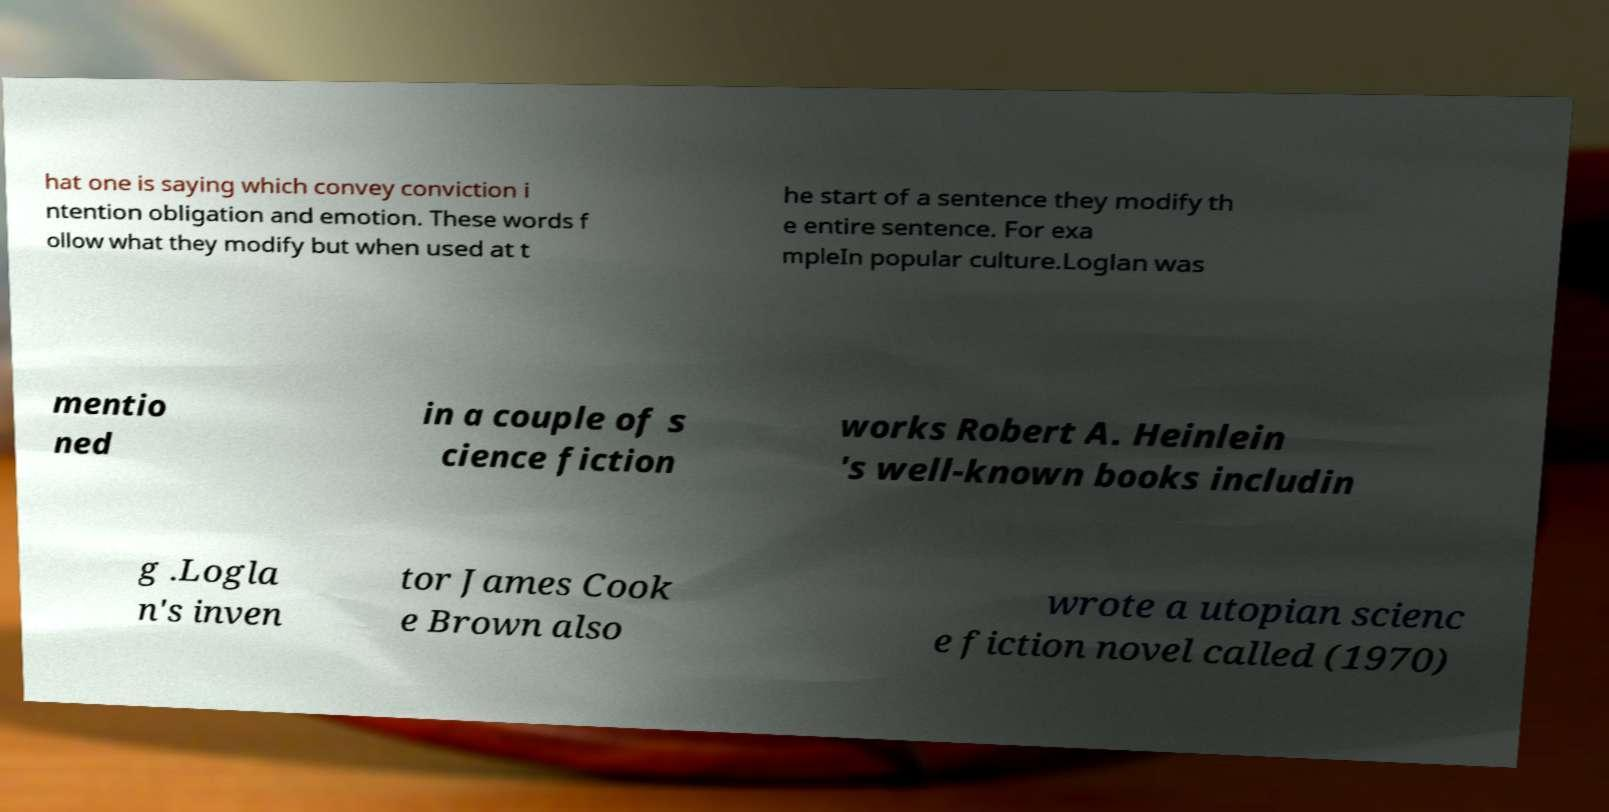Could you extract and type out the text from this image? hat one is saying which convey conviction i ntention obligation and emotion. These words f ollow what they modify but when used at t he start of a sentence they modify th e entire sentence. For exa mpleIn popular culture.Loglan was mentio ned in a couple of s cience fiction works Robert A. Heinlein 's well-known books includin g .Logla n's inven tor James Cook e Brown also wrote a utopian scienc e fiction novel called (1970) 